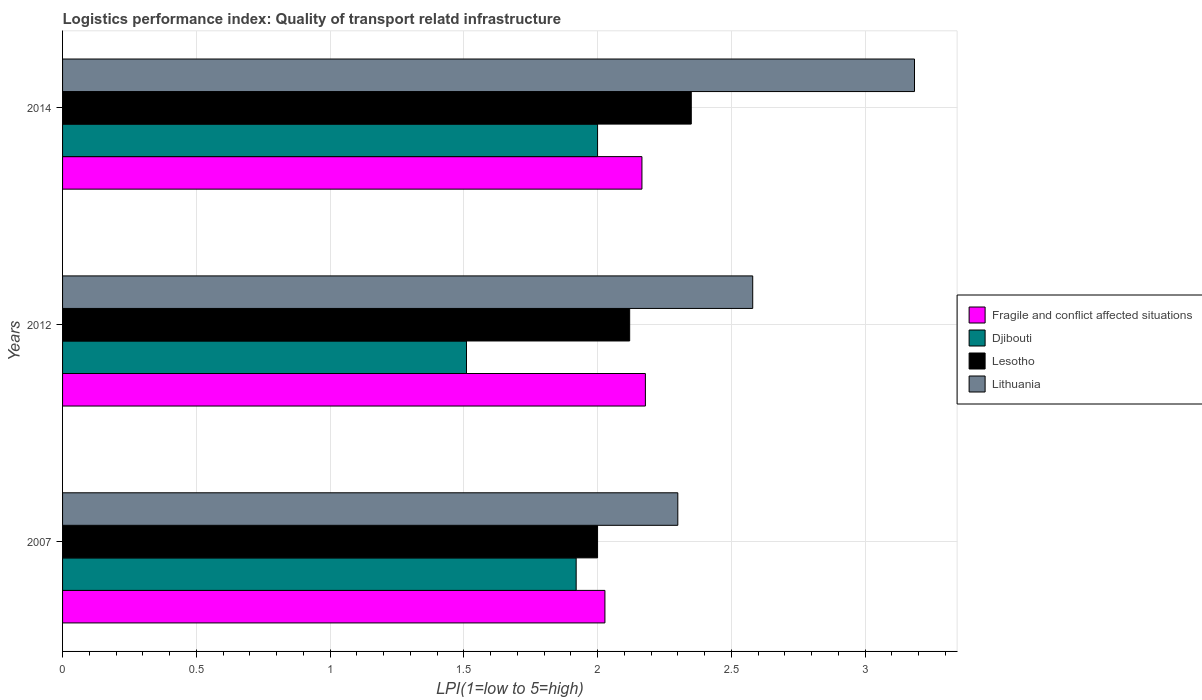How many groups of bars are there?
Keep it short and to the point. 3. How many bars are there on the 2nd tick from the bottom?
Give a very brief answer. 4. What is the label of the 2nd group of bars from the top?
Ensure brevity in your answer.  2012. What is the logistics performance index in Lesotho in 2012?
Provide a short and direct response. 2.12. Across all years, what is the maximum logistics performance index in Lithuania?
Keep it short and to the point. 3.18. Across all years, what is the minimum logistics performance index in Fragile and conflict affected situations?
Provide a succinct answer. 2.03. In which year was the logistics performance index in Fragile and conflict affected situations maximum?
Keep it short and to the point. 2012. In which year was the logistics performance index in Djibouti minimum?
Your response must be concise. 2012. What is the total logistics performance index in Lesotho in the graph?
Keep it short and to the point. 6.47. What is the difference between the logistics performance index in Lesotho in 2012 and that in 2014?
Offer a very short reply. -0.23. What is the difference between the logistics performance index in Fragile and conflict affected situations in 2014 and the logistics performance index in Lithuania in 2007?
Your answer should be very brief. -0.13. What is the average logistics performance index in Djibouti per year?
Your response must be concise. 1.81. In the year 2014, what is the difference between the logistics performance index in Lesotho and logistics performance index in Lithuania?
Ensure brevity in your answer.  -0.83. In how many years, is the logistics performance index in Djibouti greater than 1.2 ?
Provide a short and direct response. 3. What is the ratio of the logistics performance index in Djibouti in 2007 to that in 2014?
Keep it short and to the point. 0.96. Is the logistics performance index in Lithuania in 2007 less than that in 2012?
Ensure brevity in your answer.  Yes. What is the difference between the highest and the second highest logistics performance index in Djibouti?
Your answer should be compact. 0.08. What is the difference between the highest and the lowest logistics performance index in Lithuania?
Your answer should be very brief. 0.88. What does the 1st bar from the top in 2012 represents?
Offer a very short reply. Lithuania. What does the 3rd bar from the bottom in 2014 represents?
Provide a short and direct response. Lesotho. How many bars are there?
Your answer should be compact. 12. Are all the bars in the graph horizontal?
Make the answer very short. Yes. What is the difference between two consecutive major ticks on the X-axis?
Provide a short and direct response. 0.5. How are the legend labels stacked?
Give a very brief answer. Vertical. What is the title of the graph?
Your answer should be compact. Logistics performance index: Quality of transport relatd infrastructure. What is the label or title of the X-axis?
Offer a very short reply. LPI(1=low to 5=high). What is the LPI(1=low to 5=high) of Fragile and conflict affected situations in 2007?
Keep it short and to the point. 2.03. What is the LPI(1=low to 5=high) of Djibouti in 2007?
Your answer should be compact. 1.92. What is the LPI(1=low to 5=high) in Lesotho in 2007?
Your answer should be very brief. 2. What is the LPI(1=low to 5=high) in Lithuania in 2007?
Your answer should be compact. 2.3. What is the LPI(1=low to 5=high) of Fragile and conflict affected situations in 2012?
Ensure brevity in your answer.  2.18. What is the LPI(1=low to 5=high) of Djibouti in 2012?
Offer a terse response. 1.51. What is the LPI(1=low to 5=high) in Lesotho in 2012?
Offer a terse response. 2.12. What is the LPI(1=low to 5=high) in Lithuania in 2012?
Provide a succinct answer. 2.58. What is the LPI(1=low to 5=high) in Fragile and conflict affected situations in 2014?
Offer a very short reply. 2.17. What is the LPI(1=low to 5=high) of Djibouti in 2014?
Offer a very short reply. 2. What is the LPI(1=low to 5=high) of Lesotho in 2014?
Provide a succinct answer. 2.35. What is the LPI(1=low to 5=high) of Lithuania in 2014?
Your response must be concise. 3.18. Across all years, what is the maximum LPI(1=low to 5=high) in Fragile and conflict affected situations?
Offer a terse response. 2.18. Across all years, what is the maximum LPI(1=low to 5=high) in Djibouti?
Your answer should be compact. 2. Across all years, what is the maximum LPI(1=low to 5=high) in Lesotho?
Your response must be concise. 2.35. Across all years, what is the maximum LPI(1=low to 5=high) of Lithuania?
Make the answer very short. 3.18. Across all years, what is the minimum LPI(1=low to 5=high) in Fragile and conflict affected situations?
Ensure brevity in your answer.  2.03. Across all years, what is the minimum LPI(1=low to 5=high) in Djibouti?
Give a very brief answer. 1.51. Across all years, what is the minimum LPI(1=low to 5=high) of Lesotho?
Offer a terse response. 2. Across all years, what is the minimum LPI(1=low to 5=high) of Lithuania?
Ensure brevity in your answer.  2.3. What is the total LPI(1=low to 5=high) of Fragile and conflict affected situations in the graph?
Provide a short and direct response. 6.37. What is the total LPI(1=low to 5=high) of Djibouti in the graph?
Offer a very short reply. 5.43. What is the total LPI(1=low to 5=high) of Lesotho in the graph?
Your response must be concise. 6.47. What is the total LPI(1=low to 5=high) in Lithuania in the graph?
Your response must be concise. 8.06. What is the difference between the LPI(1=low to 5=high) of Fragile and conflict affected situations in 2007 and that in 2012?
Ensure brevity in your answer.  -0.15. What is the difference between the LPI(1=low to 5=high) of Djibouti in 2007 and that in 2012?
Keep it short and to the point. 0.41. What is the difference between the LPI(1=low to 5=high) in Lesotho in 2007 and that in 2012?
Your answer should be very brief. -0.12. What is the difference between the LPI(1=low to 5=high) in Lithuania in 2007 and that in 2012?
Offer a terse response. -0.28. What is the difference between the LPI(1=low to 5=high) of Fragile and conflict affected situations in 2007 and that in 2014?
Make the answer very short. -0.14. What is the difference between the LPI(1=low to 5=high) in Djibouti in 2007 and that in 2014?
Offer a very short reply. -0.08. What is the difference between the LPI(1=low to 5=high) in Lesotho in 2007 and that in 2014?
Provide a short and direct response. -0.35. What is the difference between the LPI(1=low to 5=high) of Lithuania in 2007 and that in 2014?
Provide a succinct answer. -0.88. What is the difference between the LPI(1=low to 5=high) of Fragile and conflict affected situations in 2012 and that in 2014?
Provide a short and direct response. 0.01. What is the difference between the LPI(1=low to 5=high) of Djibouti in 2012 and that in 2014?
Ensure brevity in your answer.  -0.49. What is the difference between the LPI(1=low to 5=high) in Lesotho in 2012 and that in 2014?
Provide a short and direct response. -0.23. What is the difference between the LPI(1=low to 5=high) of Lithuania in 2012 and that in 2014?
Offer a very short reply. -0.6. What is the difference between the LPI(1=low to 5=high) of Fragile and conflict affected situations in 2007 and the LPI(1=low to 5=high) of Djibouti in 2012?
Your answer should be very brief. 0.52. What is the difference between the LPI(1=low to 5=high) in Fragile and conflict affected situations in 2007 and the LPI(1=low to 5=high) in Lesotho in 2012?
Make the answer very short. -0.09. What is the difference between the LPI(1=low to 5=high) of Fragile and conflict affected situations in 2007 and the LPI(1=low to 5=high) of Lithuania in 2012?
Your response must be concise. -0.55. What is the difference between the LPI(1=low to 5=high) of Djibouti in 2007 and the LPI(1=low to 5=high) of Lesotho in 2012?
Give a very brief answer. -0.2. What is the difference between the LPI(1=low to 5=high) of Djibouti in 2007 and the LPI(1=low to 5=high) of Lithuania in 2012?
Your answer should be compact. -0.66. What is the difference between the LPI(1=low to 5=high) of Lesotho in 2007 and the LPI(1=low to 5=high) of Lithuania in 2012?
Make the answer very short. -0.58. What is the difference between the LPI(1=low to 5=high) of Fragile and conflict affected situations in 2007 and the LPI(1=low to 5=high) of Djibouti in 2014?
Your answer should be compact. 0.03. What is the difference between the LPI(1=low to 5=high) in Fragile and conflict affected situations in 2007 and the LPI(1=low to 5=high) in Lesotho in 2014?
Your answer should be very brief. -0.32. What is the difference between the LPI(1=low to 5=high) of Fragile and conflict affected situations in 2007 and the LPI(1=low to 5=high) of Lithuania in 2014?
Provide a succinct answer. -1.16. What is the difference between the LPI(1=low to 5=high) of Djibouti in 2007 and the LPI(1=low to 5=high) of Lesotho in 2014?
Give a very brief answer. -0.43. What is the difference between the LPI(1=low to 5=high) in Djibouti in 2007 and the LPI(1=low to 5=high) in Lithuania in 2014?
Ensure brevity in your answer.  -1.26. What is the difference between the LPI(1=low to 5=high) of Lesotho in 2007 and the LPI(1=low to 5=high) of Lithuania in 2014?
Ensure brevity in your answer.  -1.18. What is the difference between the LPI(1=low to 5=high) of Fragile and conflict affected situations in 2012 and the LPI(1=low to 5=high) of Djibouti in 2014?
Offer a very short reply. 0.18. What is the difference between the LPI(1=low to 5=high) of Fragile and conflict affected situations in 2012 and the LPI(1=low to 5=high) of Lesotho in 2014?
Your answer should be compact. -0.17. What is the difference between the LPI(1=low to 5=high) in Fragile and conflict affected situations in 2012 and the LPI(1=low to 5=high) in Lithuania in 2014?
Offer a terse response. -1.01. What is the difference between the LPI(1=low to 5=high) in Djibouti in 2012 and the LPI(1=low to 5=high) in Lesotho in 2014?
Keep it short and to the point. -0.84. What is the difference between the LPI(1=low to 5=high) in Djibouti in 2012 and the LPI(1=low to 5=high) in Lithuania in 2014?
Give a very brief answer. -1.67. What is the difference between the LPI(1=low to 5=high) in Lesotho in 2012 and the LPI(1=low to 5=high) in Lithuania in 2014?
Give a very brief answer. -1.06. What is the average LPI(1=low to 5=high) of Fragile and conflict affected situations per year?
Offer a very short reply. 2.12. What is the average LPI(1=low to 5=high) in Djibouti per year?
Make the answer very short. 1.81. What is the average LPI(1=low to 5=high) in Lesotho per year?
Provide a succinct answer. 2.16. What is the average LPI(1=low to 5=high) of Lithuania per year?
Ensure brevity in your answer.  2.69. In the year 2007, what is the difference between the LPI(1=low to 5=high) in Fragile and conflict affected situations and LPI(1=low to 5=high) in Djibouti?
Keep it short and to the point. 0.11. In the year 2007, what is the difference between the LPI(1=low to 5=high) of Fragile and conflict affected situations and LPI(1=low to 5=high) of Lesotho?
Make the answer very short. 0.03. In the year 2007, what is the difference between the LPI(1=low to 5=high) in Fragile and conflict affected situations and LPI(1=low to 5=high) in Lithuania?
Provide a succinct answer. -0.27. In the year 2007, what is the difference between the LPI(1=low to 5=high) of Djibouti and LPI(1=low to 5=high) of Lesotho?
Make the answer very short. -0.08. In the year 2007, what is the difference between the LPI(1=low to 5=high) of Djibouti and LPI(1=low to 5=high) of Lithuania?
Ensure brevity in your answer.  -0.38. In the year 2007, what is the difference between the LPI(1=low to 5=high) in Lesotho and LPI(1=low to 5=high) in Lithuania?
Offer a terse response. -0.3. In the year 2012, what is the difference between the LPI(1=low to 5=high) in Fragile and conflict affected situations and LPI(1=low to 5=high) in Djibouti?
Keep it short and to the point. 0.67. In the year 2012, what is the difference between the LPI(1=low to 5=high) of Fragile and conflict affected situations and LPI(1=low to 5=high) of Lesotho?
Offer a very short reply. 0.06. In the year 2012, what is the difference between the LPI(1=low to 5=high) in Fragile and conflict affected situations and LPI(1=low to 5=high) in Lithuania?
Your answer should be compact. -0.4. In the year 2012, what is the difference between the LPI(1=low to 5=high) of Djibouti and LPI(1=low to 5=high) of Lesotho?
Your answer should be compact. -0.61. In the year 2012, what is the difference between the LPI(1=low to 5=high) in Djibouti and LPI(1=low to 5=high) in Lithuania?
Offer a terse response. -1.07. In the year 2012, what is the difference between the LPI(1=low to 5=high) of Lesotho and LPI(1=low to 5=high) of Lithuania?
Your answer should be compact. -0.46. In the year 2014, what is the difference between the LPI(1=low to 5=high) of Fragile and conflict affected situations and LPI(1=low to 5=high) of Djibouti?
Your response must be concise. 0.17. In the year 2014, what is the difference between the LPI(1=low to 5=high) of Fragile and conflict affected situations and LPI(1=low to 5=high) of Lesotho?
Your answer should be very brief. -0.18. In the year 2014, what is the difference between the LPI(1=low to 5=high) of Fragile and conflict affected situations and LPI(1=low to 5=high) of Lithuania?
Provide a succinct answer. -1.02. In the year 2014, what is the difference between the LPI(1=low to 5=high) of Djibouti and LPI(1=low to 5=high) of Lesotho?
Offer a very short reply. -0.35. In the year 2014, what is the difference between the LPI(1=low to 5=high) in Djibouti and LPI(1=low to 5=high) in Lithuania?
Offer a very short reply. -1.18. In the year 2014, what is the difference between the LPI(1=low to 5=high) in Lesotho and LPI(1=low to 5=high) in Lithuania?
Offer a terse response. -0.83. What is the ratio of the LPI(1=low to 5=high) of Fragile and conflict affected situations in 2007 to that in 2012?
Offer a very short reply. 0.93. What is the ratio of the LPI(1=low to 5=high) in Djibouti in 2007 to that in 2012?
Provide a succinct answer. 1.27. What is the ratio of the LPI(1=low to 5=high) of Lesotho in 2007 to that in 2012?
Offer a very short reply. 0.94. What is the ratio of the LPI(1=low to 5=high) of Lithuania in 2007 to that in 2012?
Keep it short and to the point. 0.89. What is the ratio of the LPI(1=low to 5=high) in Fragile and conflict affected situations in 2007 to that in 2014?
Keep it short and to the point. 0.94. What is the ratio of the LPI(1=low to 5=high) in Lesotho in 2007 to that in 2014?
Ensure brevity in your answer.  0.85. What is the ratio of the LPI(1=low to 5=high) of Lithuania in 2007 to that in 2014?
Offer a terse response. 0.72. What is the ratio of the LPI(1=low to 5=high) of Fragile and conflict affected situations in 2012 to that in 2014?
Make the answer very short. 1.01. What is the ratio of the LPI(1=low to 5=high) of Djibouti in 2012 to that in 2014?
Provide a succinct answer. 0.76. What is the ratio of the LPI(1=low to 5=high) of Lesotho in 2012 to that in 2014?
Your response must be concise. 0.9. What is the ratio of the LPI(1=low to 5=high) in Lithuania in 2012 to that in 2014?
Your answer should be very brief. 0.81. What is the difference between the highest and the second highest LPI(1=low to 5=high) of Fragile and conflict affected situations?
Your answer should be compact. 0.01. What is the difference between the highest and the second highest LPI(1=low to 5=high) of Djibouti?
Offer a terse response. 0.08. What is the difference between the highest and the second highest LPI(1=low to 5=high) in Lesotho?
Give a very brief answer. 0.23. What is the difference between the highest and the second highest LPI(1=low to 5=high) of Lithuania?
Ensure brevity in your answer.  0.6. What is the difference between the highest and the lowest LPI(1=low to 5=high) in Fragile and conflict affected situations?
Ensure brevity in your answer.  0.15. What is the difference between the highest and the lowest LPI(1=low to 5=high) of Djibouti?
Ensure brevity in your answer.  0.49. What is the difference between the highest and the lowest LPI(1=low to 5=high) in Lesotho?
Your answer should be very brief. 0.35. What is the difference between the highest and the lowest LPI(1=low to 5=high) in Lithuania?
Ensure brevity in your answer.  0.88. 